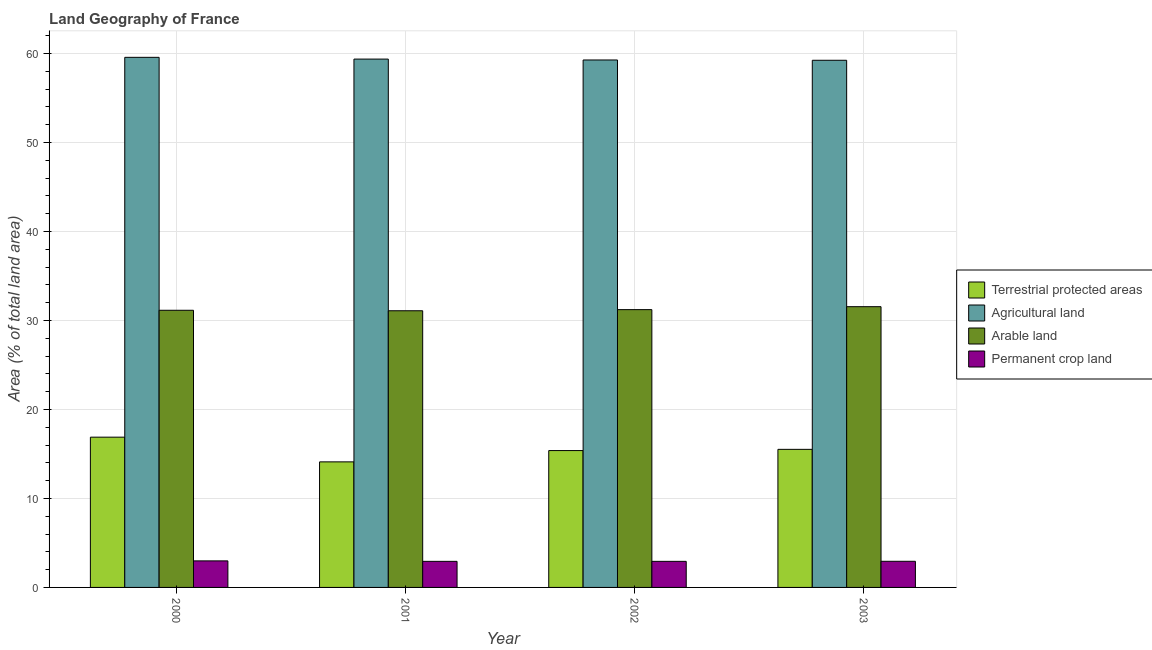How many different coloured bars are there?
Give a very brief answer. 4. How many groups of bars are there?
Provide a short and direct response. 4. Are the number of bars per tick equal to the number of legend labels?
Your response must be concise. Yes. Are the number of bars on each tick of the X-axis equal?
Provide a succinct answer. Yes. How many bars are there on the 1st tick from the left?
Keep it short and to the point. 4. In how many cases, is the number of bars for a given year not equal to the number of legend labels?
Ensure brevity in your answer.  0. What is the percentage of area under permanent crop land in 2001?
Ensure brevity in your answer.  2.93. Across all years, what is the maximum percentage of area under arable land?
Your answer should be very brief. 31.55. Across all years, what is the minimum percentage of area under agricultural land?
Offer a terse response. 59.25. In which year was the percentage of area under arable land minimum?
Make the answer very short. 2001. What is the total percentage of area under permanent crop land in the graph?
Your response must be concise. 11.78. What is the difference between the percentage of area under permanent crop land in 2000 and that in 2003?
Ensure brevity in your answer.  0.05. What is the difference between the percentage of area under agricultural land in 2003 and the percentage of area under permanent crop land in 2002?
Offer a terse response. -0.03. What is the average percentage of land under terrestrial protection per year?
Make the answer very short. 15.47. In the year 2002, what is the difference between the percentage of area under arable land and percentage of area under agricultural land?
Your answer should be very brief. 0. In how many years, is the percentage of land under terrestrial protection greater than 46 %?
Provide a succinct answer. 0. What is the ratio of the percentage of area under permanent crop land in 2002 to that in 2003?
Your answer should be very brief. 1. Is the difference between the percentage of area under arable land in 2001 and 2002 greater than the difference between the percentage of area under agricultural land in 2001 and 2002?
Provide a succinct answer. No. What is the difference between the highest and the second highest percentage of area under agricultural land?
Your response must be concise. 0.2. What is the difference between the highest and the lowest percentage of land under terrestrial protection?
Offer a terse response. 2.78. In how many years, is the percentage of land under terrestrial protection greater than the average percentage of land under terrestrial protection taken over all years?
Your response must be concise. 2. Is it the case that in every year, the sum of the percentage of area under permanent crop land and percentage of area under arable land is greater than the sum of percentage of area under agricultural land and percentage of land under terrestrial protection?
Keep it short and to the point. No. What does the 4th bar from the left in 2000 represents?
Give a very brief answer. Permanent crop land. What does the 3rd bar from the right in 2000 represents?
Offer a terse response. Agricultural land. Is it the case that in every year, the sum of the percentage of land under terrestrial protection and percentage of area under agricultural land is greater than the percentage of area under arable land?
Give a very brief answer. Yes. How many bars are there?
Provide a succinct answer. 16. How many years are there in the graph?
Provide a succinct answer. 4. What is the difference between two consecutive major ticks on the Y-axis?
Your answer should be compact. 10. Are the values on the major ticks of Y-axis written in scientific E-notation?
Offer a very short reply. No. How are the legend labels stacked?
Make the answer very short. Vertical. What is the title of the graph?
Provide a short and direct response. Land Geography of France. Does "Insurance services" appear as one of the legend labels in the graph?
Make the answer very short. No. What is the label or title of the Y-axis?
Offer a terse response. Area (% of total land area). What is the Area (% of total land area) in Terrestrial protected areas in 2000?
Provide a short and direct response. 16.89. What is the Area (% of total land area) in Agricultural land in 2000?
Give a very brief answer. 59.58. What is the Area (% of total land area) of Arable land in 2000?
Your response must be concise. 31.15. What is the Area (% of total land area) of Permanent crop land in 2000?
Your answer should be compact. 2.98. What is the Area (% of total land area) in Terrestrial protected areas in 2001?
Your answer should be very brief. 14.11. What is the Area (% of total land area) of Agricultural land in 2001?
Ensure brevity in your answer.  59.38. What is the Area (% of total land area) of Arable land in 2001?
Offer a terse response. 31.1. What is the Area (% of total land area) in Permanent crop land in 2001?
Make the answer very short. 2.93. What is the Area (% of total land area) of Terrestrial protected areas in 2002?
Your answer should be compact. 15.38. What is the Area (% of total land area) in Agricultural land in 2002?
Your answer should be compact. 59.28. What is the Area (% of total land area) in Arable land in 2002?
Your response must be concise. 31.22. What is the Area (% of total land area) of Permanent crop land in 2002?
Provide a succinct answer. 2.93. What is the Area (% of total land area) of Terrestrial protected areas in 2003?
Your answer should be very brief. 15.52. What is the Area (% of total land area) in Agricultural land in 2003?
Your answer should be compact. 59.25. What is the Area (% of total land area) of Arable land in 2003?
Your answer should be very brief. 31.55. What is the Area (% of total land area) of Permanent crop land in 2003?
Make the answer very short. 2.94. Across all years, what is the maximum Area (% of total land area) of Terrestrial protected areas?
Offer a terse response. 16.89. Across all years, what is the maximum Area (% of total land area) in Agricultural land?
Give a very brief answer. 59.58. Across all years, what is the maximum Area (% of total land area) in Arable land?
Ensure brevity in your answer.  31.55. Across all years, what is the maximum Area (% of total land area) of Permanent crop land?
Ensure brevity in your answer.  2.98. Across all years, what is the minimum Area (% of total land area) in Terrestrial protected areas?
Make the answer very short. 14.11. Across all years, what is the minimum Area (% of total land area) of Agricultural land?
Provide a succinct answer. 59.25. Across all years, what is the minimum Area (% of total land area) in Arable land?
Your response must be concise. 31.1. Across all years, what is the minimum Area (% of total land area) in Permanent crop land?
Keep it short and to the point. 2.93. What is the total Area (% of total land area) in Terrestrial protected areas in the graph?
Provide a succinct answer. 61.9. What is the total Area (% of total land area) in Agricultural land in the graph?
Keep it short and to the point. 237.49. What is the total Area (% of total land area) of Arable land in the graph?
Your response must be concise. 125.02. What is the total Area (% of total land area) in Permanent crop land in the graph?
Give a very brief answer. 11.78. What is the difference between the Area (% of total land area) in Terrestrial protected areas in 2000 and that in 2001?
Offer a very short reply. 2.78. What is the difference between the Area (% of total land area) of Agricultural land in 2000 and that in 2001?
Your answer should be very brief. 0.2. What is the difference between the Area (% of total land area) in Arable land in 2000 and that in 2001?
Your answer should be very brief. 0.05. What is the difference between the Area (% of total land area) of Permanent crop land in 2000 and that in 2001?
Provide a succinct answer. 0.05. What is the difference between the Area (% of total land area) of Terrestrial protected areas in 2000 and that in 2002?
Your answer should be very brief. 1.51. What is the difference between the Area (% of total land area) of Agricultural land in 2000 and that in 2002?
Keep it short and to the point. 0.3. What is the difference between the Area (% of total land area) of Arable land in 2000 and that in 2002?
Your answer should be very brief. -0.07. What is the difference between the Area (% of total land area) of Permanent crop land in 2000 and that in 2002?
Your response must be concise. 0.05. What is the difference between the Area (% of total land area) in Terrestrial protected areas in 2000 and that in 2003?
Make the answer very short. 1.37. What is the difference between the Area (% of total land area) of Agricultural land in 2000 and that in 2003?
Offer a very short reply. 0.33. What is the difference between the Area (% of total land area) in Arable land in 2000 and that in 2003?
Offer a very short reply. -0.41. What is the difference between the Area (% of total land area) in Permanent crop land in 2000 and that in 2003?
Provide a short and direct response. 0.05. What is the difference between the Area (% of total land area) of Terrestrial protected areas in 2001 and that in 2002?
Offer a terse response. -1.27. What is the difference between the Area (% of total land area) of Agricultural land in 2001 and that in 2002?
Give a very brief answer. 0.1. What is the difference between the Area (% of total land area) of Arable land in 2001 and that in 2002?
Provide a short and direct response. -0.13. What is the difference between the Area (% of total land area) of Permanent crop land in 2001 and that in 2002?
Give a very brief answer. 0. What is the difference between the Area (% of total land area) of Terrestrial protected areas in 2001 and that in 2003?
Provide a short and direct response. -1.41. What is the difference between the Area (% of total land area) in Agricultural land in 2001 and that in 2003?
Make the answer very short. 0.13. What is the difference between the Area (% of total land area) in Arable land in 2001 and that in 2003?
Your answer should be compact. -0.46. What is the difference between the Area (% of total land area) in Permanent crop land in 2001 and that in 2003?
Your answer should be very brief. -0.01. What is the difference between the Area (% of total land area) of Terrestrial protected areas in 2002 and that in 2003?
Offer a terse response. -0.14. What is the difference between the Area (% of total land area) in Agricultural land in 2002 and that in 2003?
Offer a terse response. 0.03. What is the difference between the Area (% of total land area) in Arable land in 2002 and that in 2003?
Offer a very short reply. -0.33. What is the difference between the Area (% of total land area) in Permanent crop land in 2002 and that in 2003?
Offer a terse response. -0.01. What is the difference between the Area (% of total land area) of Terrestrial protected areas in 2000 and the Area (% of total land area) of Agricultural land in 2001?
Offer a terse response. -42.49. What is the difference between the Area (% of total land area) of Terrestrial protected areas in 2000 and the Area (% of total land area) of Arable land in 2001?
Ensure brevity in your answer.  -14.21. What is the difference between the Area (% of total land area) in Terrestrial protected areas in 2000 and the Area (% of total land area) in Permanent crop land in 2001?
Ensure brevity in your answer.  13.96. What is the difference between the Area (% of total land area) of Agricultural land in 2000 and the Area (% of total land area) of Arable land in 2001?
Provide a short and direct response. 28.48. What is the difference between the Area (% of total land area) in Agricultural land in 2000 and the Area (% of total land area) in Permanent crop land in 2001?
Offer a terse response. 56.65. What is the difference between the Area (% of total land area) in Arable land in 2000 and the Area (% of total land area) in Permanent crop land in 2001?
Provide a short and direct response. 28.22. What is the difference between the Area (% of total land area) of Terrestrial protected areas in 2000 and the Area (% of total land area) of Agricultural land in 2002?
Ensure brevity in your answer.  -42.39. What is the difference between the Area (% of total land area) in Terrestrial protected areas in 2000 and the Area (% of total land area) in Arable land in 2002?
Your response must be concise. -14.33. What is the difference between the Area (% of total land area) of Terrestrial protected areas in 2000 and the Area (% of total land area) of Permanent crop land in 2002?
Offer a very short reply. 13.96. What is the difference between the Area (% of total land area) of Agricultural land in 2000 and the Area (% of total land area) of Arable land in 2002?
Your answer should be compact. 28.36. What is the difference between the Area (% of total land area) in Agricultural land in 2000 and the Area (% of total land area) in Permanent crop land in 2002?
Provide a short and direct response. 56.65. What is the difference between the Area (% of total land area) in Arable land in 2000 and the Area (% of total land area) in Permanent crop land in 2002?
Your answer should be very brief. 28.22. What is the difference between the Area (% of total land area) of Terrestrial protected areas in 2000 and the Area (% of total land area) of Agricultural land in 2003?
Ensure brevity in your answer.  -42.36. What is the difference between the Area (% of total land area) of Terrestrial protected areas in 2000 and the Area (% of total land area) of Arable land in 2003?
Offer a very short reply. -14.67. What is the difference between the Area (% of total land area) in Terrestrial protected areas in 2000 and the Area (% of total land area) in Permanent crop land in 2003?
Make the answer very short. 13.95. What is the difference between the Area (% of total land area) of Agricultural land in 2000 and the Area (% of total land area) of Arable land in 2003?
Your response must be concise. 28.02. What is the difference between the Area (% of total land area) in Agricultural land in 2000 and the Area (% of total land area) in Permanent crop land in 2003?
Give a very brief answer. 56.64. What is the difference between the Area (% of total land area) of Arable land in 2000 and the Area (% of total land area) of Permanent crop land in 2003?
Your answer should be very brief. 28.21. What is the difference between the Area (% of total land area) in Terrestrial protected areas in 2001 and the Area (% of total land area) in Agricultural land in 2002?
Keep it short and to the point. -45.17. What is the difference between the Area (% of total land area) of Terrestrial protected areas in 2001 and the Area (% of total land area) of Arable land in 2002?
Your answer should be compact. -17.11. What is the difference between the Area (% of total land area) of Terrestrial protected areas in 2001 and the Area (% of total land area) of Permanent crop land in 2002?
Offer a very short reply. 11.18. What is the difference between the Area (% of total land area) in Agricultural land in 2001 and the Area (% of total land area) in Arable land in 2002?
Offer a very short reply. 28.16. What is the difference between the Area (% of total land area) in Agricultural land in 2001 and the Area (% of total land area) in Permanent crop land in 2002?
Keep it short and to the point. 56.45. What is the difference between the Area (% of total land area) of Arable land in 2001 and the Area (% of total land area) of Permanent crop land in 2002?
Offer a very short reply. 28.16. What is the difference between the Area (% of total land area) of Terrestrial protected areas in 2001 and the Area (% of total land area) of Agricultural land in 2003?
Your answer should be very brief. -45.14. What is the difference between the Area (% of total land area) in Terrestrial protected areas in 2001 and the Area (% of total land area) in Arable land in 2003?
Your answer should be very brief. -17.44. What is the difference between the Area (% of total land area) of Terrestrial protected areas in 2001 and the Area (% of total land area) of Permanent crop land in 2003?
Your answer should be very brief. 11.17. What is the difference between the Area (% of total land area) of Agricultural land in 2001 and the Area (% of total land area) of Arable land in 2003?
Give a very brief answer. 27.83. What is the difference between the Area (% of total land area) of Agricultural land in 2001 and the Area (% of total land area) of Permanent crop land in 2003?
Your response must be concise. 56.44. What is the difference between the Area (% of total land area) of Arable land in 2001 and the Area (% of total land area) of Permanent crop land in 2003?
Provide a succinct answer. 28.16. What is the difference between the Area (% of total land area) of Terrestrial protected areas in 2002 and the Area (% of total land area) of Agricultural land in 2003?
Provide a short and direct response. -43.87. What is the difference between the Area (% of total land area) in Terrestrial protected areas in 2002 and the Area (% of total land area) in Arable land in 2003?
Offer a terse response. -16.17. What is the difference between the Area (% of total land area) in Terrestrial protected areas in 2002 and the Area (% of total land area) in Permanent crop land in 2003?
Provide a short and direct response. 12.44. What is the difference between the Area (% of total land area) of Agricultural land in 2002 and the Area (% of total land area) of Arable land in 2003?
Offer a very short reply. 27.73. What is the difference between the Area (% of total land area) of Agricultural land in 2002 and the Area (% of total land area) of Permanent crop land in 2003?
Keep it short and to the point. 56.34. What is the difference between the Area (% of total land area) in Arable land in 2002 and the Area (% of total land area) in Permanent crop land in 2003?
Keep it short and to the point. 28.28. What is the average Area (% of total land area) of Terrestrial protected areas per year?
Offer a terse response. 15.47. What is the average Area (% of total land area) in Agricultural land per year?
Provide a short and direct response. 59.37. What is the average Area (% of total land area) in Arable land per year?
Your answer should be compact. 31.26. What is the average Area (% of total land area) in Permanent crop land per year?
Provide a short and direct response. 2.95. In the year 2000, what is the difference between the Area (% of total land area) of Terrestrial protected areas and Area (% of total land area) of Agricultural land?
Your response must be concise. -42.69. In the year 2000, what is the difference between the Area (% of total land area) in Terrestrial protected areas and Area (% of total land area) in Arable land?
Your answer should be compact. -14.26. In the year 2000, what is the difference between the Area (% of total land area) of Terrestrial protected areas and Area (% of total land area) of Permanent crop land?
Provide a short and direct response. 13.9. In the year 2000, what is the difference between the Area (% of total land area) in Agricultural land and Area (% of total land area) in Arable land?
Offer a terse response. 28.43. In the year 2000, what is the difference between the Area (% of total land area) of Agricultural land and Area (% of total land area) of Permanent crop land?
Provide a succinct answer. 56.59. In the year 2000, what is the difference between the Area (% of total land area) in Arable land and Area (% of total land area) in Permanent crop land?
Keep it short and to the point. 28.16. In the year 2001, what is the difference between the Area (% of total land area) of Terrestrial protected areas and Area (% of total land area) of Agricultural land?
Offer a terse response. -45.27. In the year 2001, what is the difference between the Area (% of total land area) in Terrestrial protected areas and Area (% of total land area) in Arable land?
Offer a terse response. -16.98. In the year 2001, what is the difference between the Area (% of total land area) in Terrestrial protected areas and Area (% of total land area) in Permanent crop land?
Your answer should be very brief. 11.18. In the year 2001, what is the difference between the Area (% of total land area) of Agricultural land and Area (% of total land area) of Arable land?
Make the answer very short. 28.29. In the year 2001, what is the difference between the Area (% of total land area) of Agricultural land and Area (% of total land area) of Permanent crop land?
Ensure brevity in your answer.  56.45. In the year 2001, what is the difference between the Area (% of total land area) in Arable land and Area (% of total land area) in Permanent crop land?
Offer a very short reply. 28.16. In the year 2002, what is the difference between the Area (% of total land area) of Terrestrial protected areas and Area (% of total land area) of Agricultural land?
Your response must be concise. -43.9. In the year 2002, what is the difference between the Area (% of total land area) in Terrestrial protected areas and Area (% of total land area) in Arable land?
Your response must be concise. -15.84. In the year 2002, what is the difference between the Area (% of total land area) of Terrestrial protected areas and Area (% of total land area) of Permanent crop land?
Keep it short and to the point. 12.45. In the year 2002, what is the difference between the Area (% of total land area) in Agricultural land and Area (% of total land area) in Arable land?
Your answer should be very brief. 28.06. In the year 2002, what is the difference between the Area (% of total land area) of Agricultural land and Area (% of total land area) of Permanent crop land?
Ensure brevity in your answer.  56.35. In the year 2002, what is the difference between the Area (% of total land area) of Arable land and Area (% of total land area) of Permanent crop land?
Give a very brief answer. 28.29. In the year 2003, what is the difference between the Area (% of total land area) in Terrestrial protected areas and Area (% of total land area) in Agricultural land?
Offer a very short reply. -43.73. In the year 2003, what is the difference between the Area (% of total land area) in Terrestrial protected areas and Area (% of total land area) in Arable land?
Keep it short and to the point. -16.04. In the year 2003, what is the difference between the Area (% of total land area) in Terrestrial protected areas and Area (% of total land area) in Permanent crop land?
Give a very brief answer. 12.58. In the year 2003, what is the difference between the Area (% of total land area) of Agricultural land and Area (% of total land area) of Arable land?
Provide a short and direct response. 27.69. In the year 2003, what is the difference between the Area (% of total land area) of Agricultural land and Area (% of total land area) of Permanent crop land?
Keep it short and to the point. 56.31. In the year 2003, what is the difference between the Area (% of total land area) of Arable land and Area (% of total land area) of Permanent crop land?
Offer a terse response. 28.62. What is the ratio of the Area (% of total land area) of Terrestrial protected areas in 2000 to that in 2001?
Provide a succinct answer. 1.2. What is the ratio of the Area (% of total land area) of Permanent crop land in 2000 to that in 2001?
Your response must be concise. 1.02. What is the ratio of the Area (% of total land area) in Terrestrial protected areas in 2000 to that in 2002?
Offer a very short reply. 1.1. What is the ratio of the Area (% of total land area) in Permanent crop land in 2000 to that in 2002?
Ensure brevity in your answer.  1.02. What is the ratio of the Area (% of total land area) in Terrestrial protected areas in 2000 to that in 2003?
Your answer should be very brief. 1.09. What is the ratio of the Area (% of total land area) in Agricultural land in 2000 to that in 2003?
Your response must be concise. 1.01. What is the ratio of the Area (% of total land area) of Arable land in 2000 to that in 2003?
Make the answer very short. 0.99. What is the ratio of the Area (% of total land area) of Permanent crop land in 2000 to that in 2003?
Your answer should be very brief. 1.02. What is the ratio of the Area (% of total land area) of Terrestrial protected areas in 2001 to that in 2002?
Provide a short and direct response. 0.92. What is the ratio of the Area (% of total land area) of Terrestrial protected areas in 2001 to that in 2003?
Make the answer very short. 0.91. What is the ratio of the Area (% of total land area) in Arable land in 2001 to that in 2003?
Provide a succinct answer. 0.99. What is the ratio of the Area (% of total land area) in Permanent crop land in 2001 to that in 2003?
Offer a terse response. 1. What is the ratio of the Area (% of total land area) in Terrestrial protected areas in 2002 to that in 2003?
Your answer should be very brief. 0.99. What is the ratio of the Area (% of total land area) in Arable land in 2002 to that in 2003?
Offer a very short reply. 0.99. What is the difference between the highest and the second highest Area (% of total land area) of Terrestrial protected areas?
Your answer should be compact. 1.37. What is the difference between the highest and the second highest Area (% of total land area) in Agricultural land?
Provide a short and direct response. 0.2. What is the difference between the highest and the second highest Area (% of total land area) in Arable land?
Provide a short and direct response. 0.33. What is the difference between the highest and the second highest Area (% of total land area) in Permanent crop land?
Provide a short and direct response. 0.05. What is the difference between the highest and the lowest Area (% of total land area) of Terrestrial protected areas?
Your answer should be very brief. 2.78. What is the difference between the highest and the lowest Area (% of total land area) of Agricultural land?
Ensure brevity in your answer.  0.33. What is the difference between the highest and the lowest Area (% of total land area) in Arable land?
Offer a terse response. 0.46. What is the difference between the highest and the lowest Area (% of total land area) of Permanent crop land?
Offer a terse response. 0.05. 